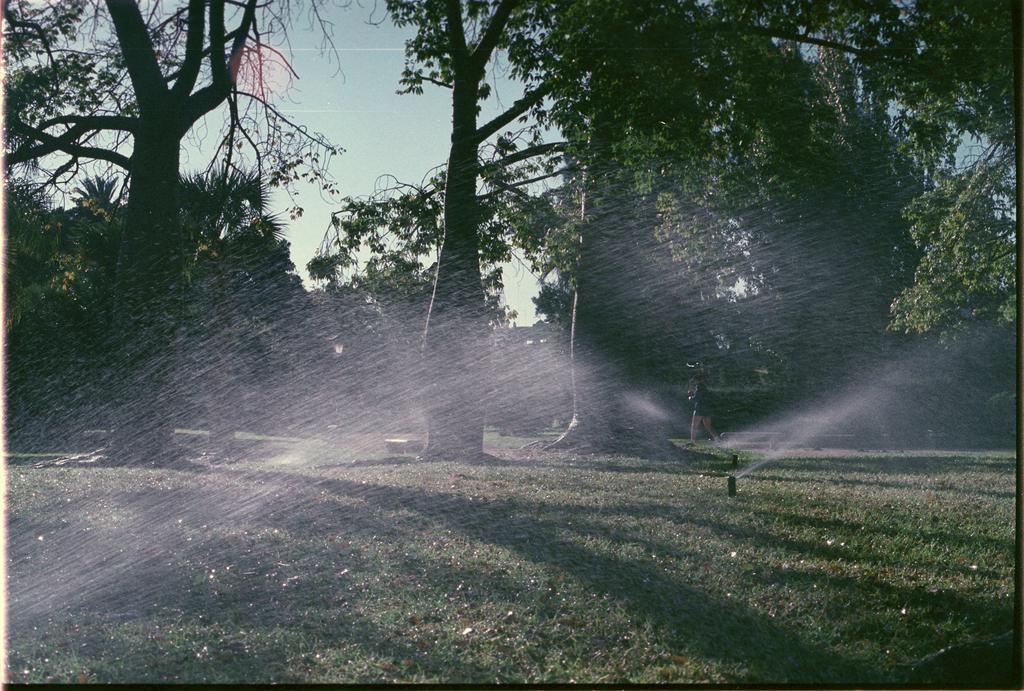Can you describe this image briefly? In this picture we can see grass, sprinklers and water. There is a person walking and we can see trees. In the background of the image we can see the sky. 